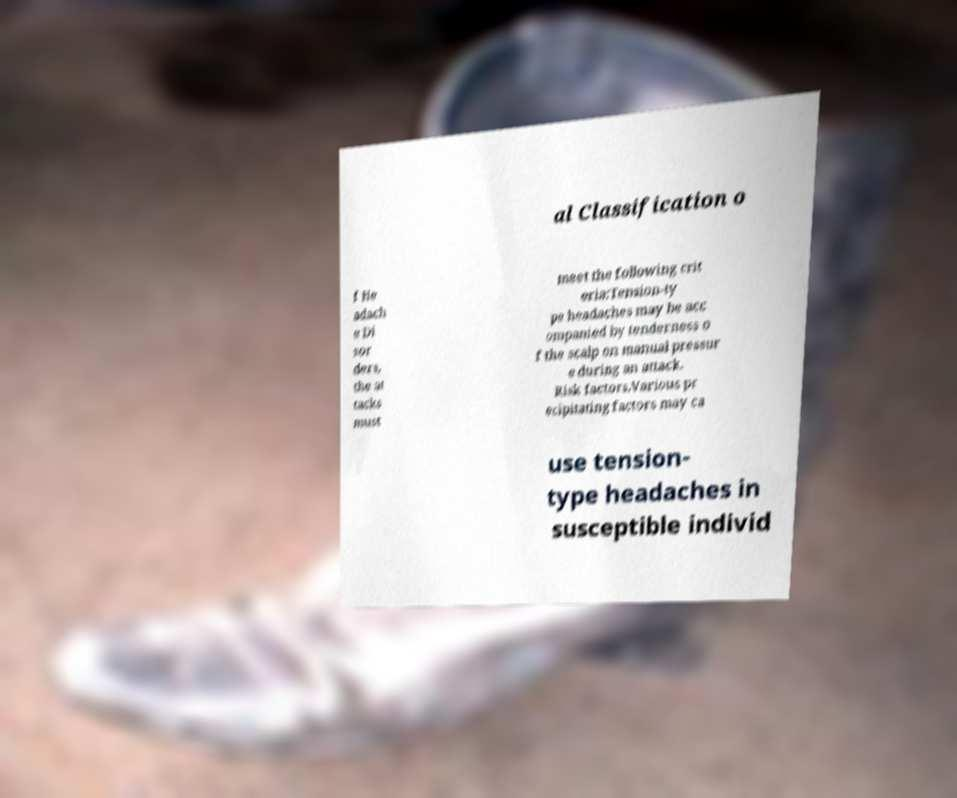Could you extract and type out the text from this image? al Classification o f He adach e Di sor ders, the at tacks must meet the following crit eria:Tension-ty pe headaches may be acc ompanied by tenderness o f the scalp on manual pressur e during an attack. Risk factors.Various pr ecipitating factors may ca use tension- type headaches in susceptible individ 